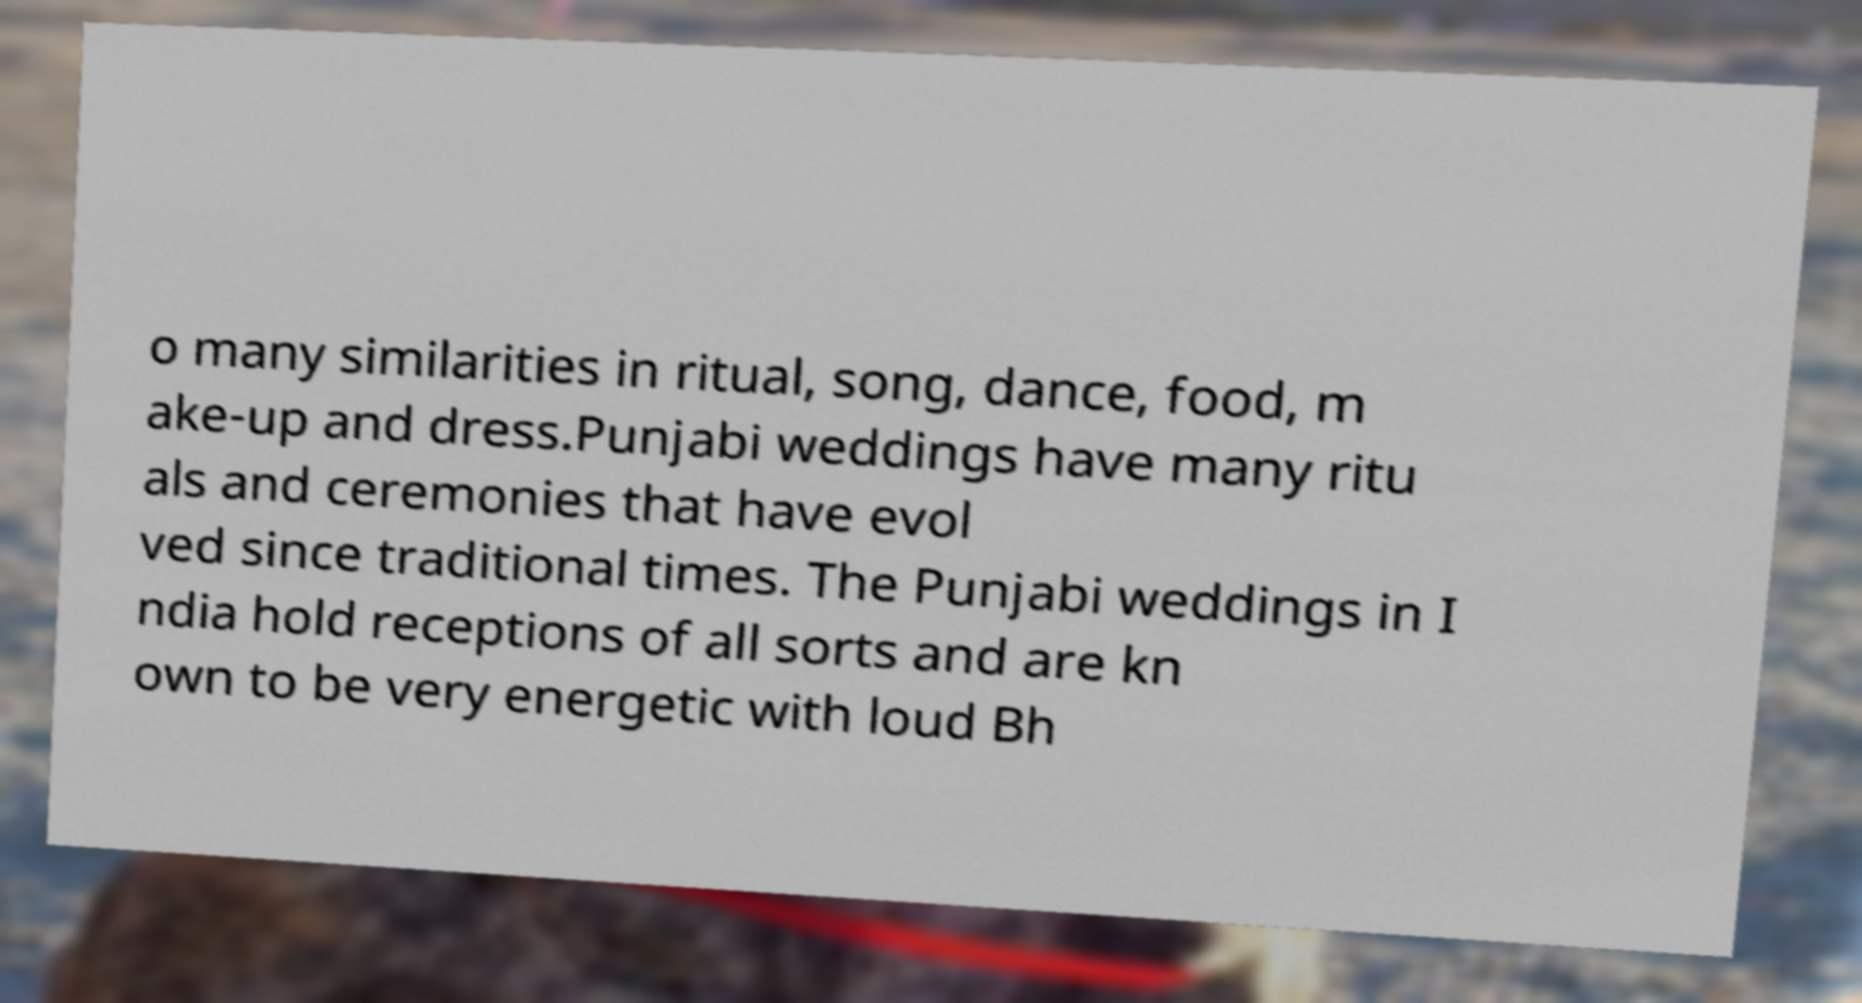For documentation purposes, I need the text within this image transcribed. Could you provide that? o many similarities in ritual, song, dance, food, m ake-up and dress.Punjabi weddings have many ritu als and ceremonies that have evol ved since traditional times. The Punjabi weddings in I ndia hold receptions of all sorts and are kn own to be very energetic with loud Bh 